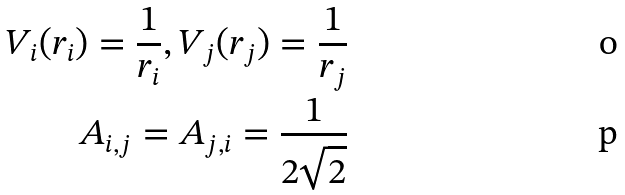<formula> <loc_0><loc_0><loc_500><loc_500>V _ { i } ( r _ { i } ) = \frac { 1 } { r _ { i } } , V _ { j } ( r _ { j } ) = \frac { 1 } { r _ { j } } \\ A _ { i , j } = A _ { j , i } = \frac { 1 } { 2 \sqrt { 2 } }</formula> 